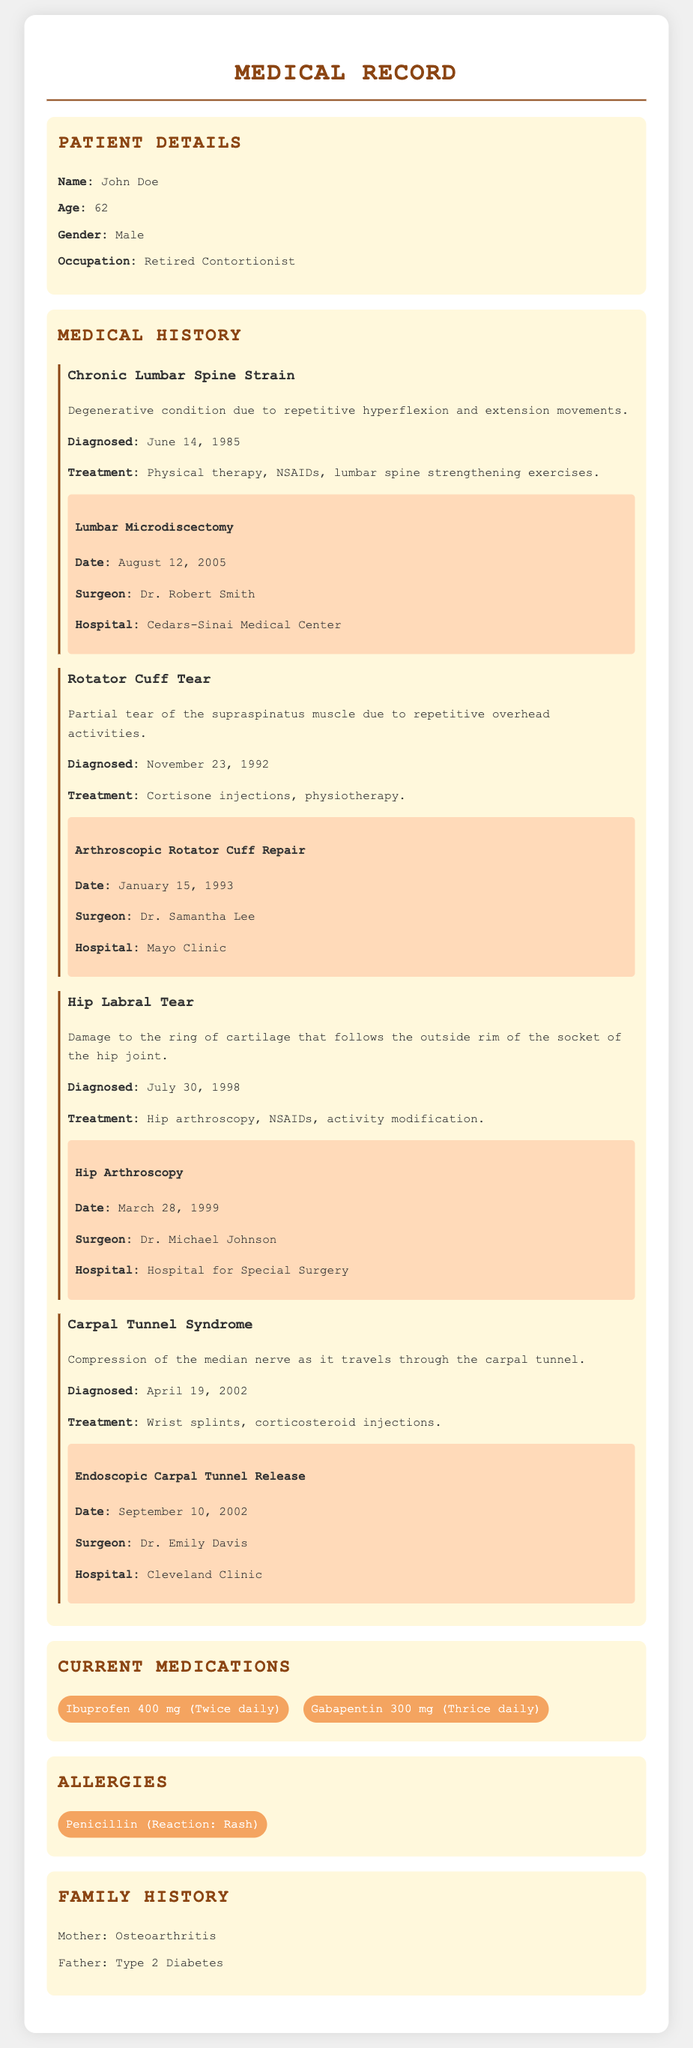What is the patient's name? The patient's name is stated in the document under Patient Details.
Answer: John Doe What is the age of the patient? The age is provided in the Patient Details section.
Answer: 62 What surgery did the patient undergo on March 28, 1999? The document lists surgeries and their dates, including this one.
Answer: Hip Arthroscopy Who performed the surgery for Carpal Tunnel Syndrome? The document mentions the surgeon’s name in the surgery section for that condition.
Answer: Dr. Emily Davis What medication is the patient taking twice daily? Current Medications section lists medications, including dosage and frequency.
Answer: Ibuprofen 400 mg How many surgeries has the patient had? The document references multiple surgeries listed under several conditions.
Answer: Four What condition is associated with the diagnosis date of June 14, 1985? The document details conditions along with their diagnosis dates.
Answer: Chronic Lumbar Spine Strain What is the patient's occupation? The patient's occupation is mentioned in the Patient Details section.
Answer: Retired Contortionist What reaction is noted for the patient's allergy to Penicillin? The allergy section provides information about the patient's reaction to the substance.
Answer: Rash 